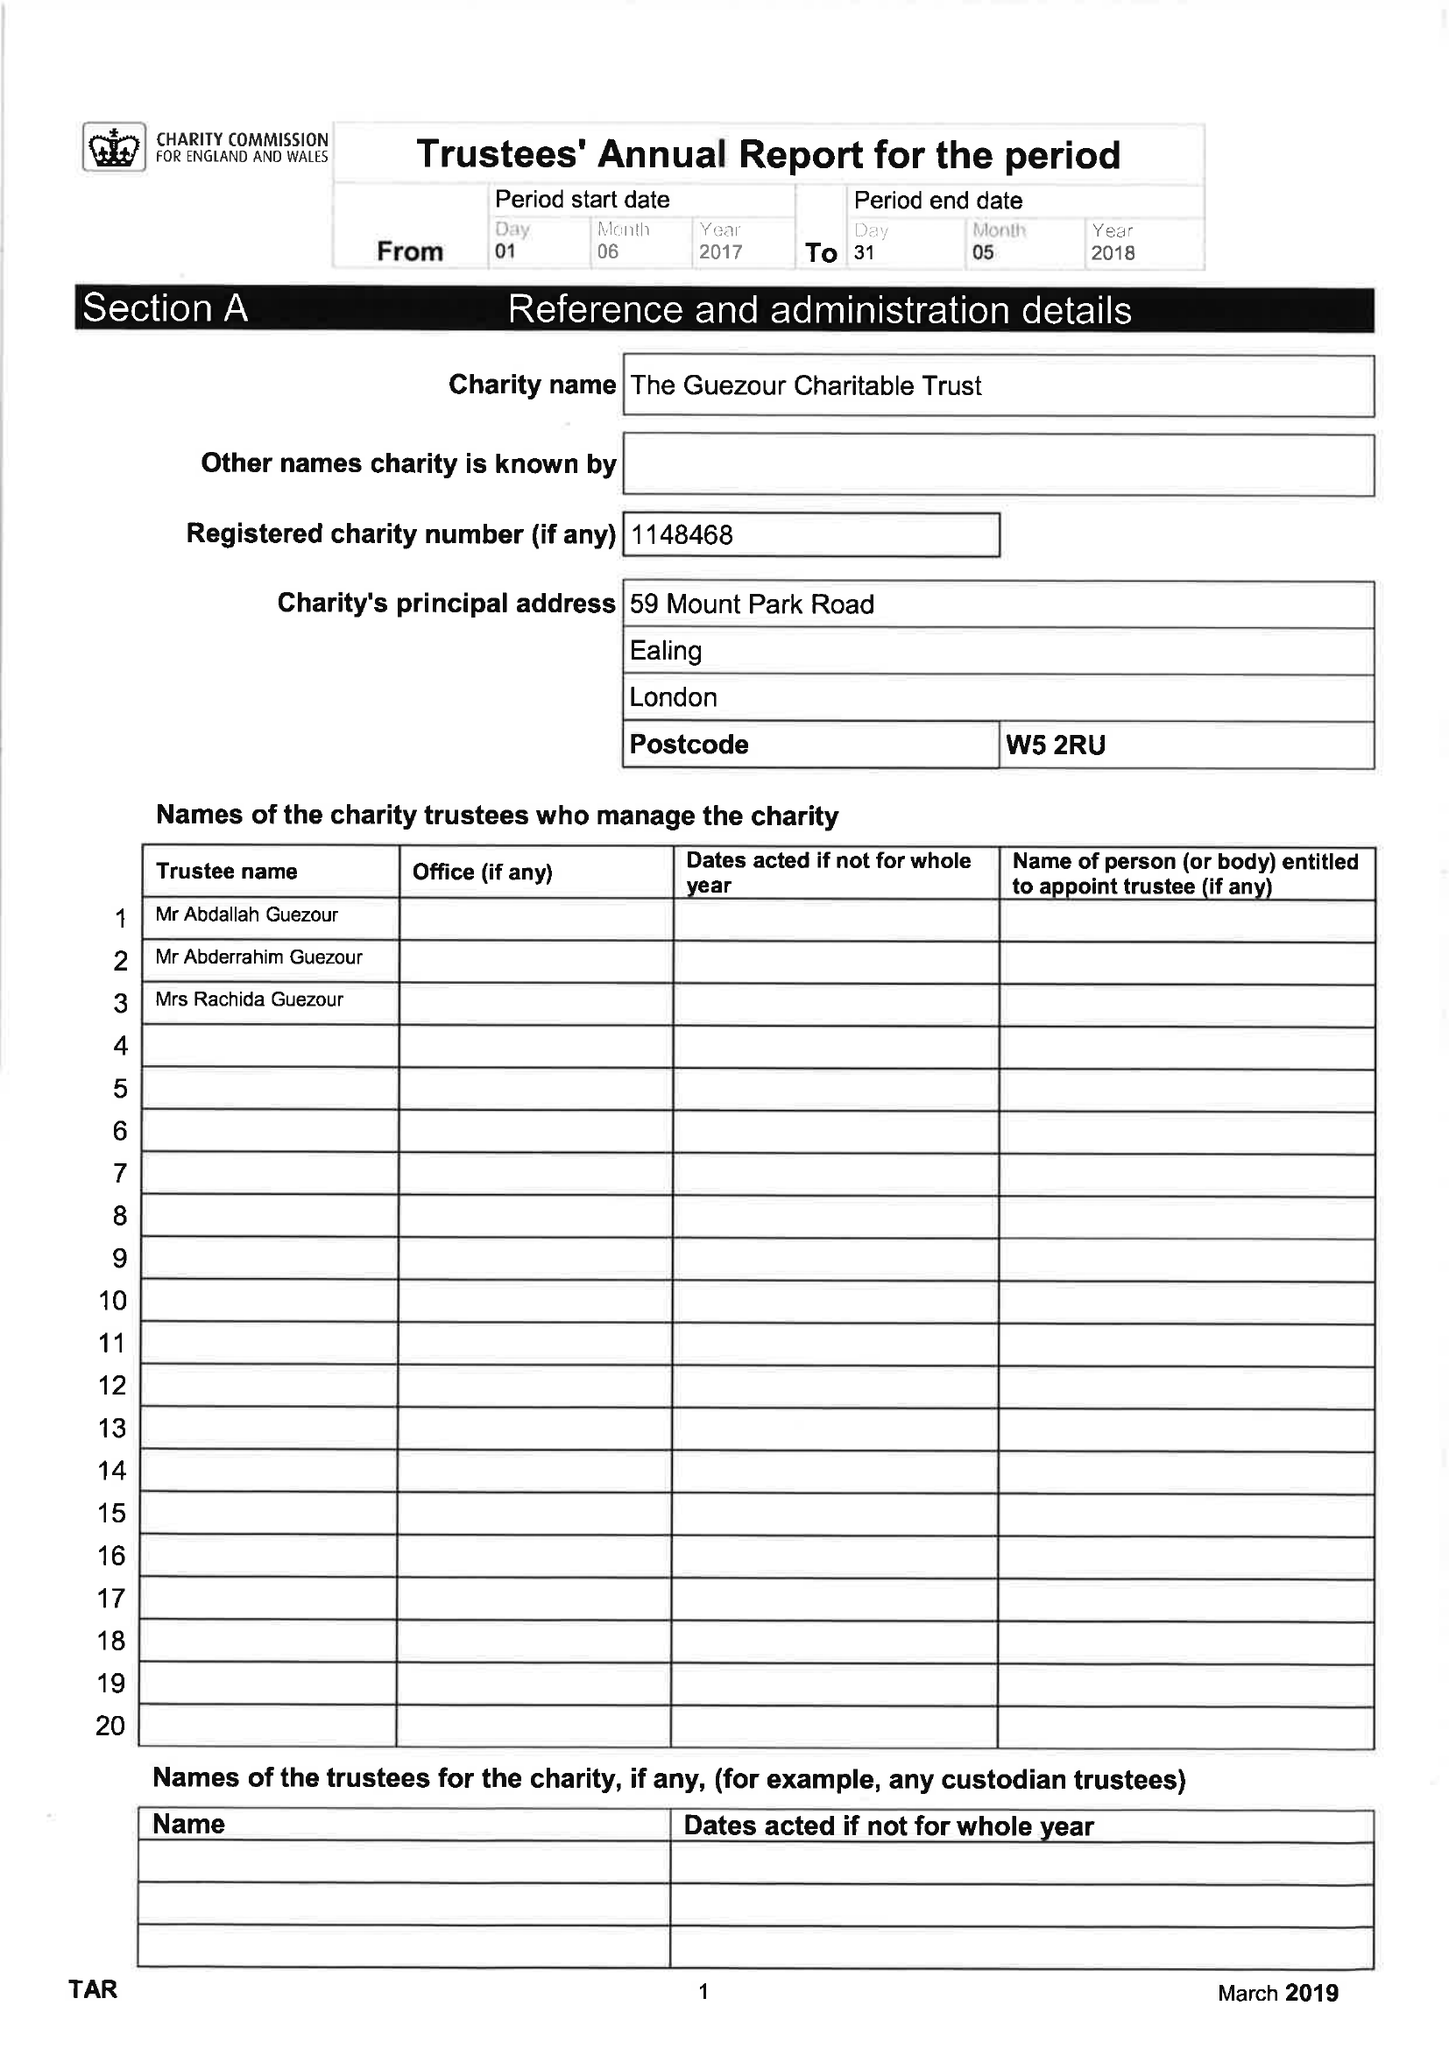What is the value for the charity_number?
Answer the question using a single word or phrase. 1148468 